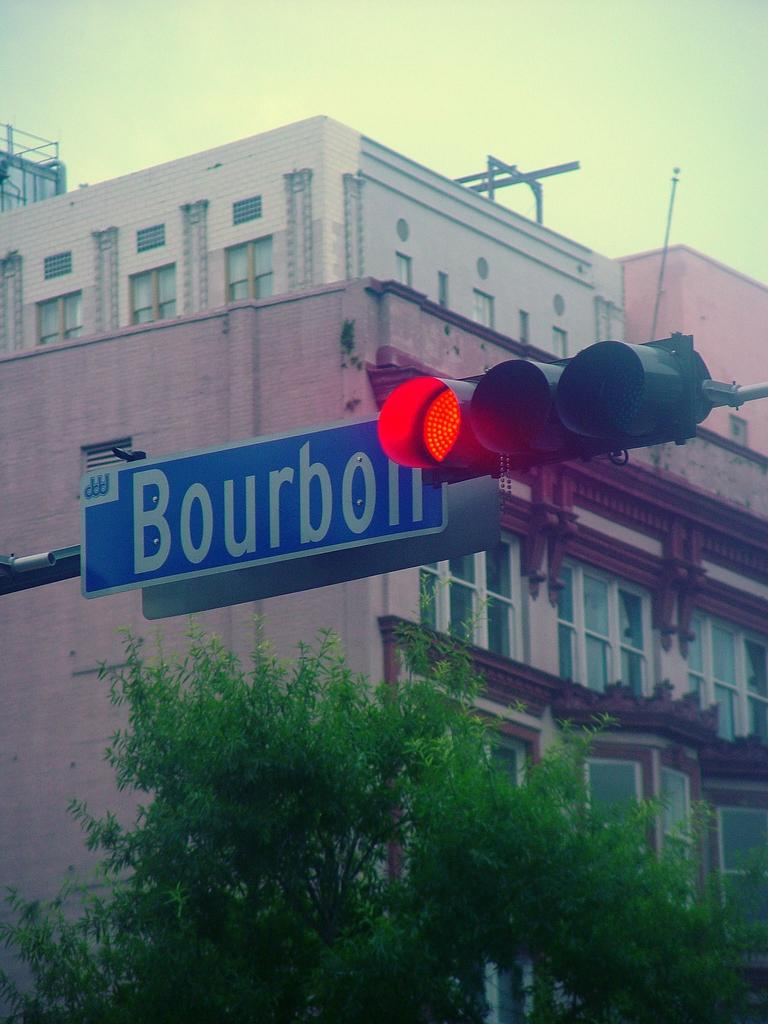<image>
Write a terse but informative summary of the picture. A traffic light is red and there is a blue street sign next to it that says Bourbon. 